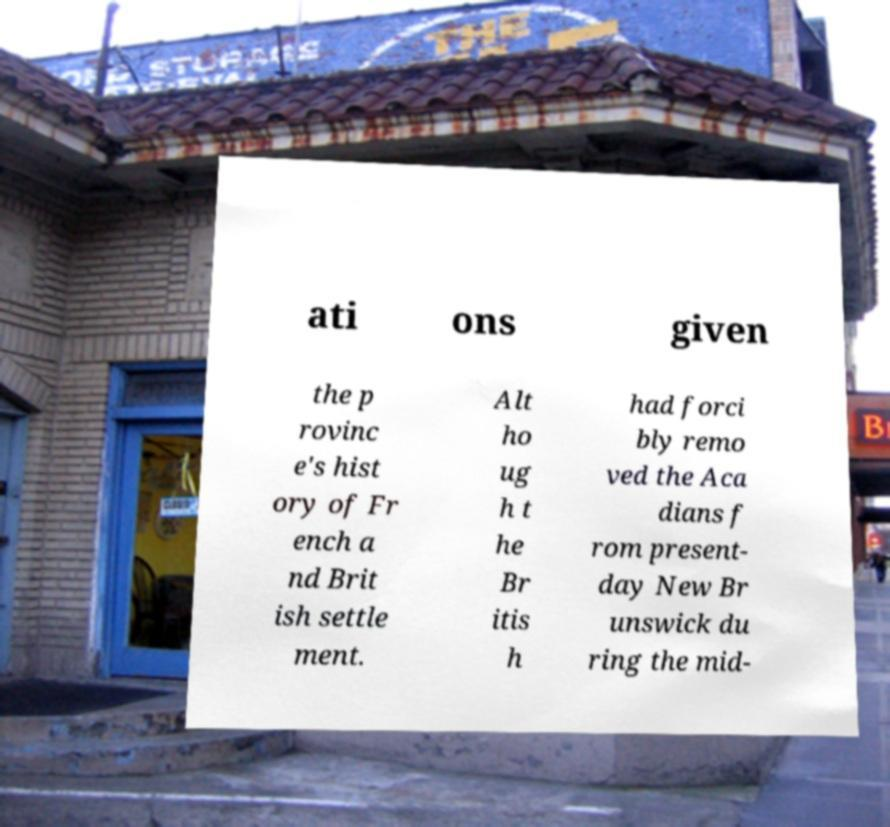Can you accurately transcribe the text from the provided image for me? ati ons given the p rovinc e's hist ory of Fr ench a nd Brit ish settle ment. Alt ho ug h t he Br itis h had forci bly remo ved the Aca dians f rom present- day New Br unswick du ring the mid- 